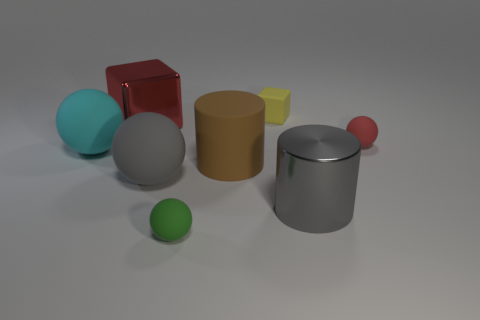The large metallic cylinder has what color?
Keep it short and to the point. Gray. Is the red sphere the same size as the cyan rubber ball?
Provide a succinct answer. No. What number of things are either small yellow cylinders or balls?
Your response must be concise. 4. Are there the same number of tiny rubber objects that are in front of the big brown rubber cylinder and cyan spheres?
Your response must be concise. Yes. Is there a large gray thing left of the small rubber sphere behind the metallic object on the right side of the big red metallic cube?
Your response must be concise. Yes. What color is the tiny cube that is made of the same material as the small red thing?
Your response must be concise. Yellow. There is a small rubber thing on the right side of the yellow block; does it have the same color as the big metal block?
Provide a short and direct response. Yes. How many cubes are either big red objects or small matte objects?
Provide a succinct answer. 2. There is a matte object that is behind the tiny rubber ball behind the large gray object that is to the right of the tiny green ball; what size is it?
Offer a very short reply. Small. What is the shape of the red object that is the same size as the green thing?
Your answer should be very brief. Sphere. 